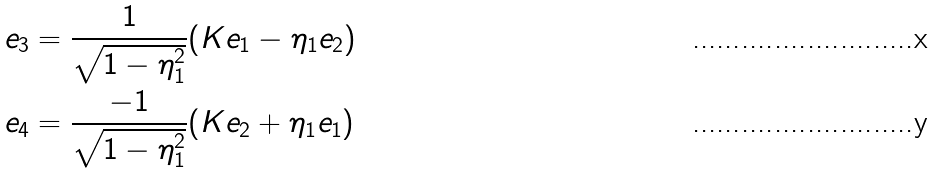<formula> <loc_0><loc_0><loc_500><loc_500>& e _ { 3 } = \frac { 1 } { \sqrt { 1 - \eta _ { 1 } ^ { 2 } } } ( K e _ { 1 } - \eta _ { 1 } e _ { 2 } ) \\ & e _ { 4 } = \frac { - 1 } { \sqrt { 1 - \eta _ { 1 } ^ { 2 } } } ( K e _ { 2 } + \eta _ { 1 } e _ { 1 } )</formula> 